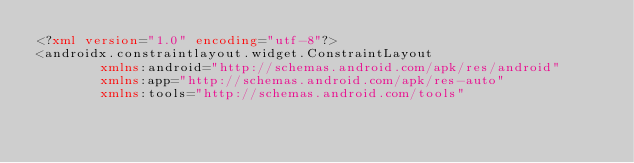<code> <loc_0><loc_0><loc_500><loc_500><_XML_><?xml version="1.0" encoding="utf-8"?>
<androidx.constraintlayout.widget.ConstraintLayout
        xmlns:android="http://schemas.android.com/apk/res/android"
        xmlns:app="http://schemas.android.com/apk/res-auto"
        xmlns:tools="http://schemas.android.com/tools"</code> 